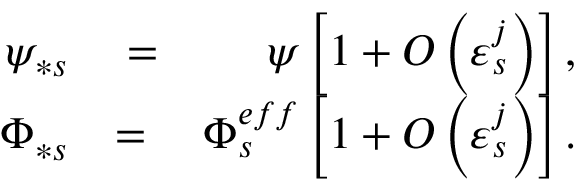Convert formula to latex. <formula><loc_0><loc_0><loc_500><loc_500>\begin{array} { r l r } { \psi _ { \ast s } } & = } & { \psi \left [ 1 + O \left ( \varepsilon _ { s } ^ { j } \right ) \right ] , } \\ { \Phi _ { \ast s } } & = } & { \Phi _ { s } ^ { e f f } \left [ 1 + O \left ( \varepsilon _ { s } ^ { j } \right ) \right ] . } \end{array}</formula> 